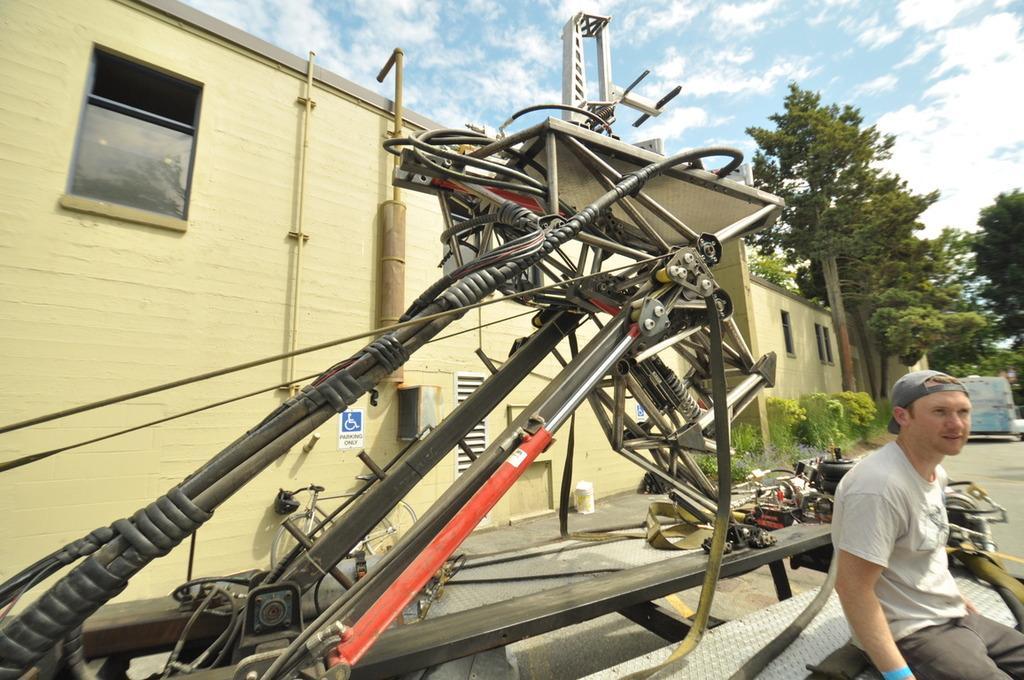Can you describe this image briefly? In the middle of the image there is a vehicle, on the vehicle a man is sitting. Behind the vehicle there is a building and there are some plants and trees. Top of the image there are some clouds and sky. 